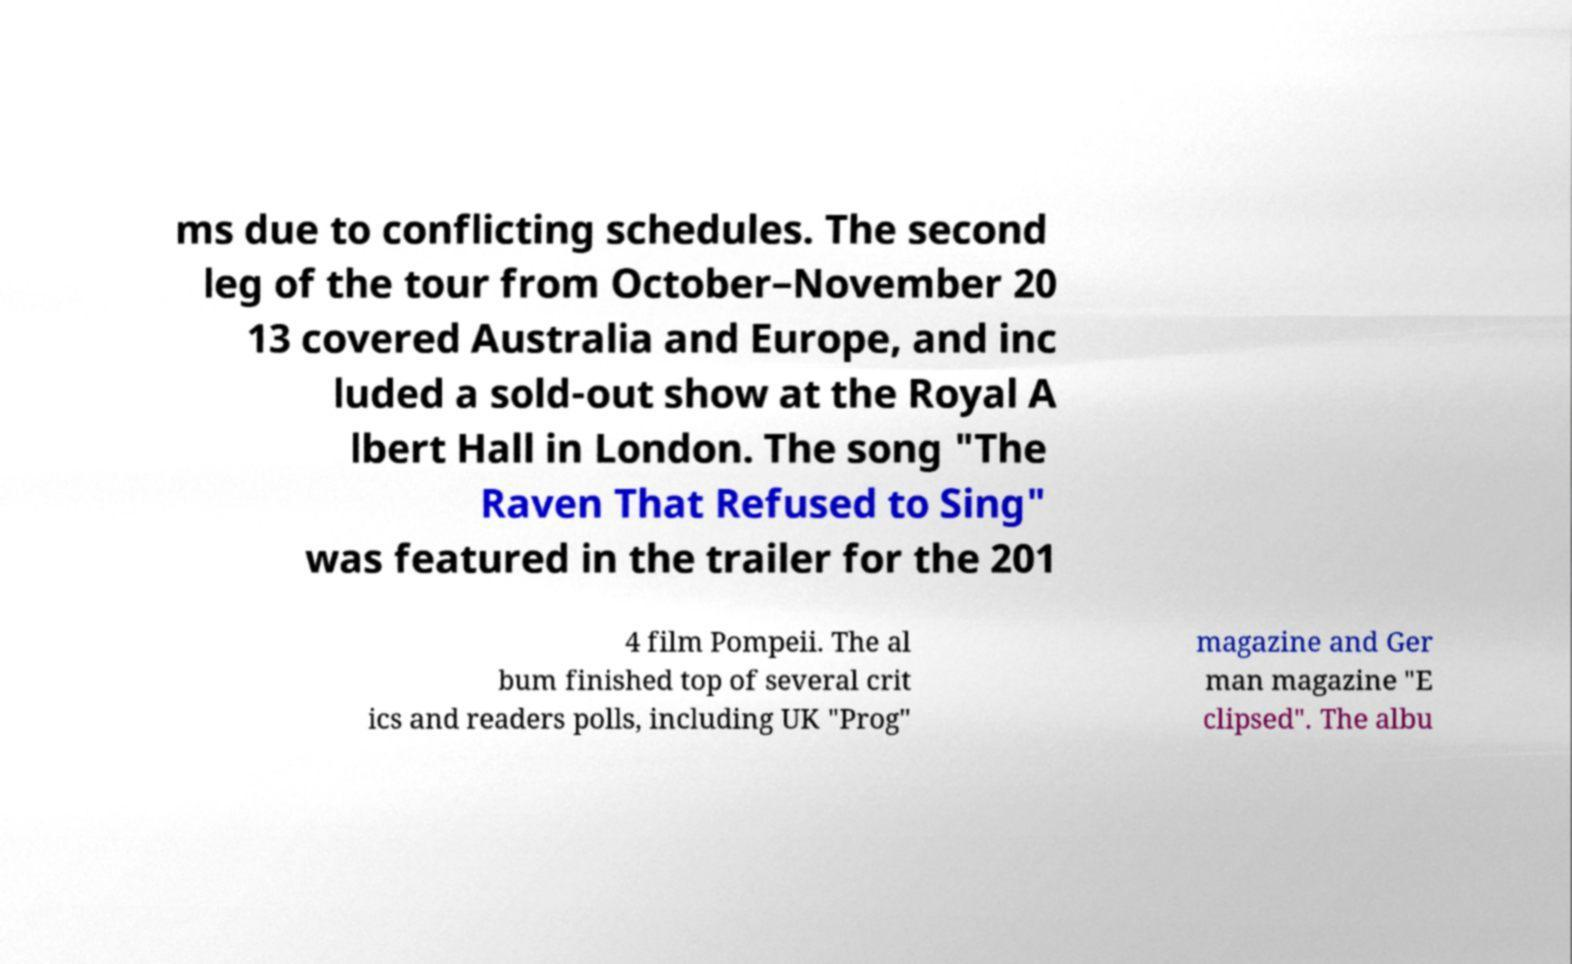I need the written content from this picture converted into text. Can you do that? ms due to conflicting schedules. The second leg of the tour from October–November 20 13 covered Australia and Europe, and inc luded a sold-out show at the Royal A lbert Hall in London. The song "The Raven That Refused to Sing" was featured in the trailer for the 201 4 film Pompeii. The al bum finished top of several crit ics and readers polls, including UK "Prog" magazine and Ger man magazine "E clipsed". The albu 